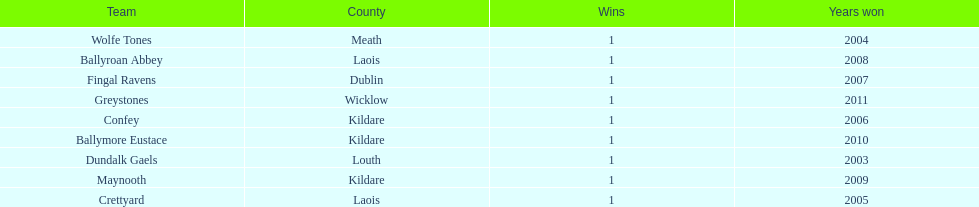Which team was the previous winner before ballyroan abbey in 2008? Fingal Ravens. 